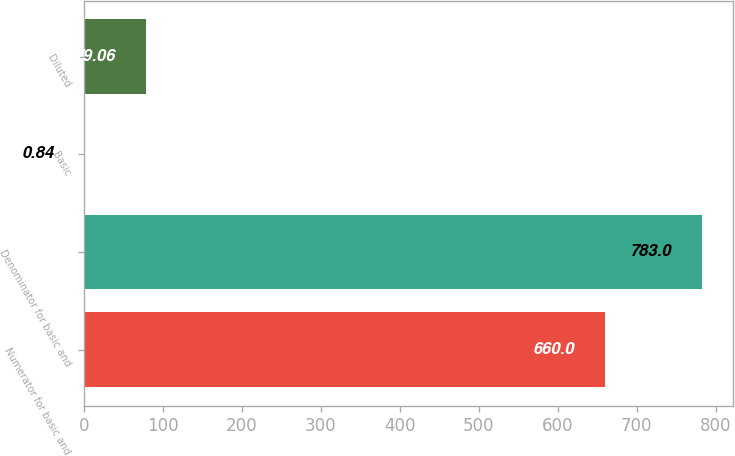Convert chart. <chart><loc_0><loc_0><loc_500><loc_500><bar_chart><fcel>Numerator for basic and<fcel>Denominator for basic and<fcel>Basic<fcel>Diluted<nl><fcel>660<fcel>783<fcel>0.84<fcel>79.06<nl></chart> 